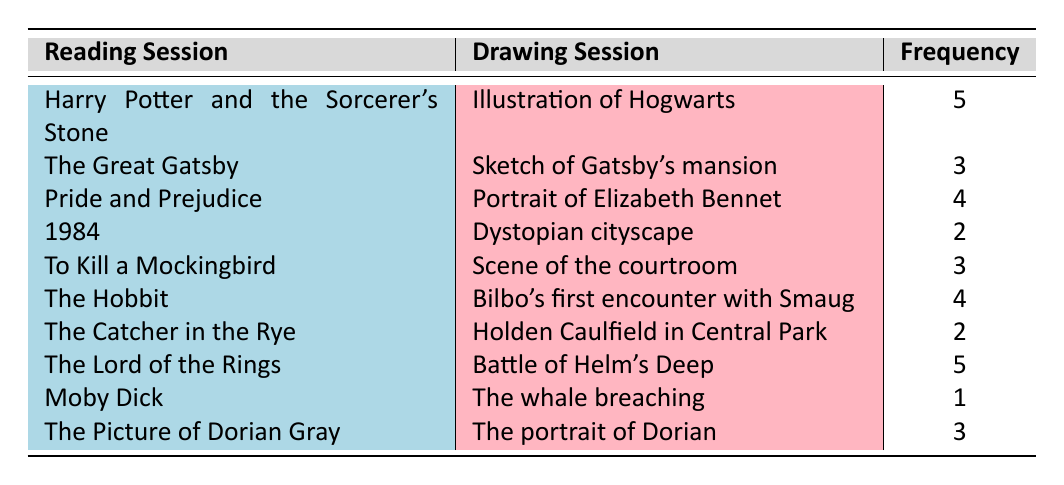What is the frequency of drawing sessions for "The Hobbit"? The table shows that for "The Hobbit," the frequency of drawing sessions is listed as 4.
Answer: 4 Which reading session has the highest frequency of drawing sessions? By comparing the frequencies in the table, "Harry Potter and the Sorcerer's Stone" and "The Lord of the Rings" both have the highest frequency at 5.
Answer: Harry Potter and the Sorcerer's Stone and The Lord of the Rings How many total drawing sessions have been conducted across all reading sessions? To find the total, we sum all the frequencies: 5 + 3 + 4 + 2 + 3 + 4 + 2 + 5 + 1 + 3 = 32.
Answer: 32 Is the frequency of drawing sessions for "Moby Dick" greater than 2? The frequency for "Moby Dick" is 1 according to the table, which is not greater than 2.
Answer: No What is the average frequency of drawing sessions for the books listed? First, we sum the frequencies: 32. Then, we count the number of reading sessions, which is 10. The average is calculated as 32/10 = 3.2.
Answer: 3.2 How many books have a drawing session frequency of 3 or more? The books with a frequency of 3 or more are: "Harry Potter and the Sorcerer's Stone" (5), "Pride and Prejudice" (4), "The Hobbit" (4), "The Lord of the Rings" (5), "The Great Gatsby" (3), "To Kill a Mockingbird" (3), and "The Picture of Dorian Gray" (3). That totals to 7 books.
Answer: 7 What is the difference in frequency between the highest and lowest drawing session frequencies? The highest frequency is 5 (for both "Harry Potter and the Sorcerer's Stone" and "The Lord of the Rings"), and the lowest is 1 (for "Moby Dick"). The difference is 5 - 1 = 4.
Answer: 4 Does "The Catcher in the Rye" have a drawing session associated with it that is greater or equal to 3? The frequency for "The Catcher in the Rye" is 2 according to the table, which is less than 3.
Answer: No 